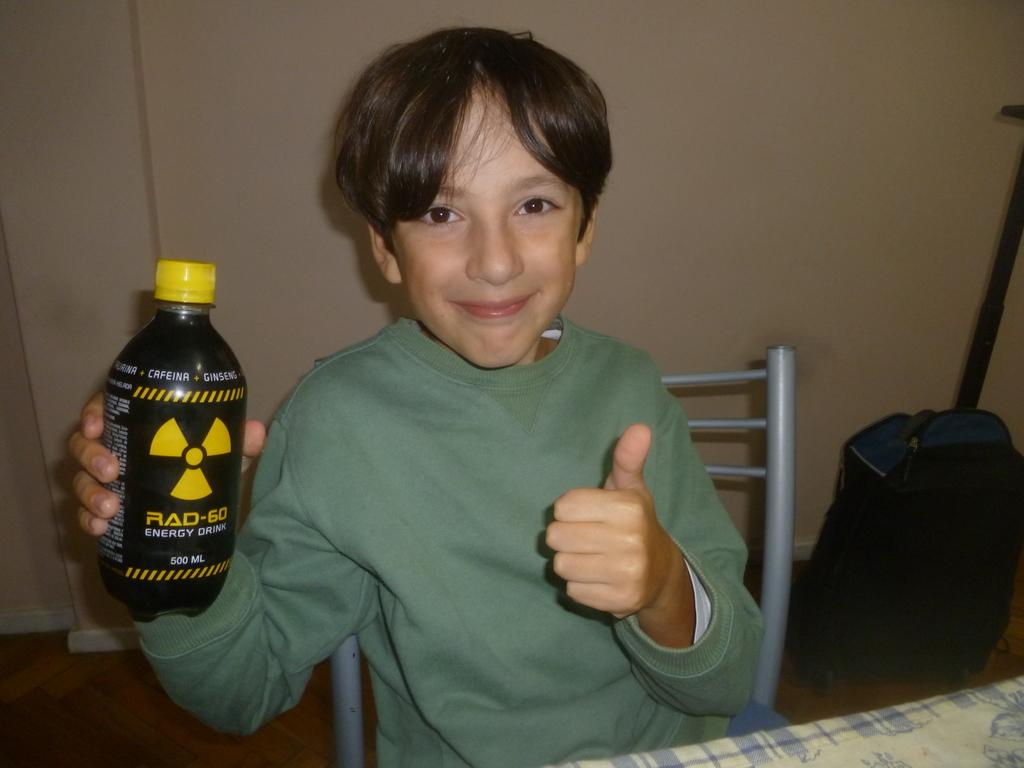Who is the main subject in the image? There is a small boy in the image. What is the boy doing in the image? The boy is sitting in a chair and catching a bottle. What is in front of the boy? There is a table in front of the boy. Can you describe any other objects in the image? There is a bag near the wall in the image. How many cats can be seen playing near the window in the image? There are no cats or windows present in the image. Is there an oven visible in the image? No, there is no oven present in the image. 